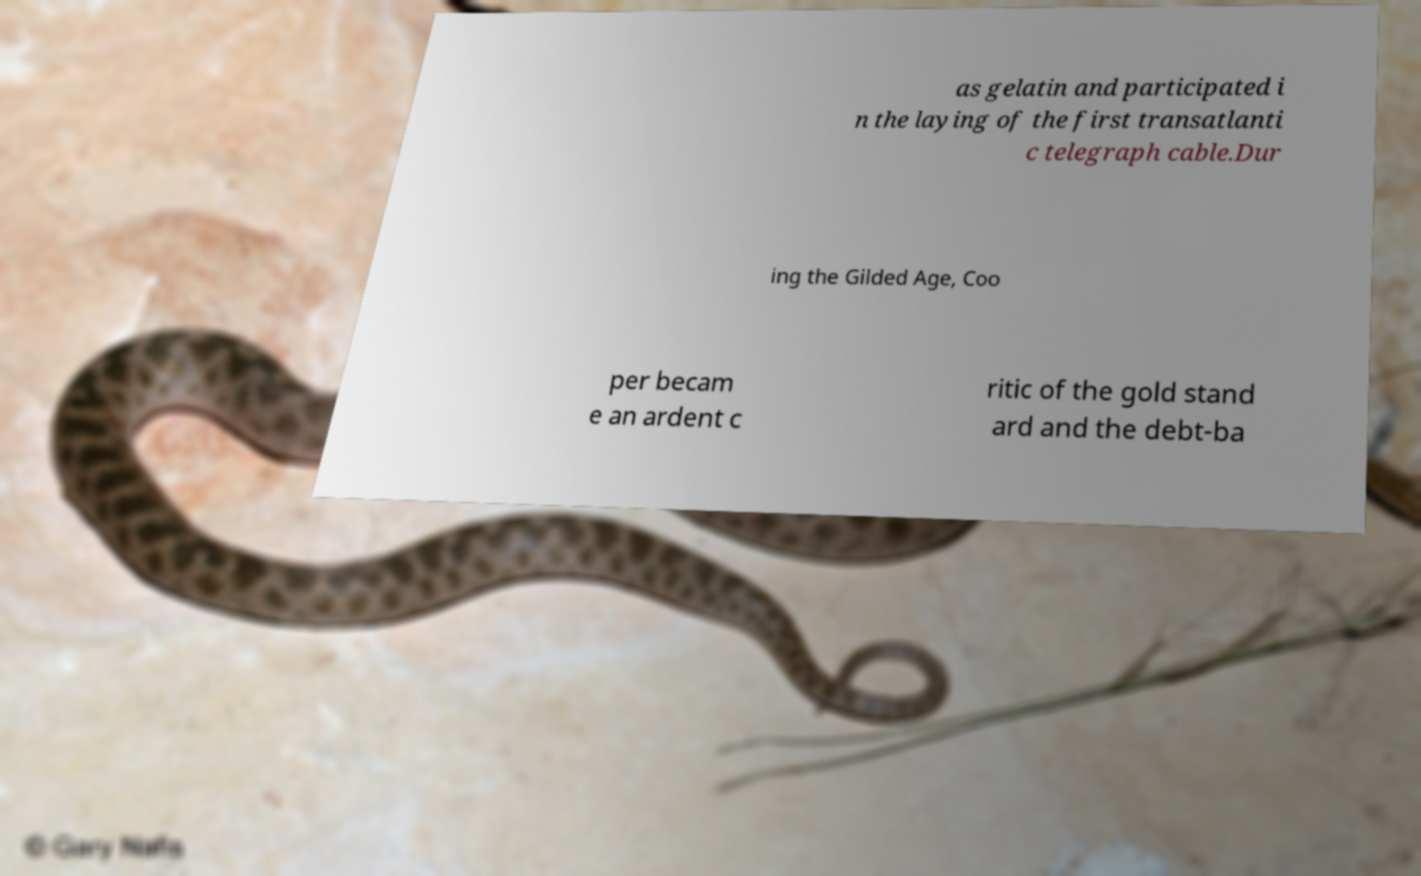There's text embedded in this image that I need extracted. Can you transcribe it verbatim? as gelatin and participated i n the laying of the first transatlanti c telegraph cable.Dur ing the Gilded Age, Coo per becam e an ardent c ritic of the gold stand ard and the debt-ba 